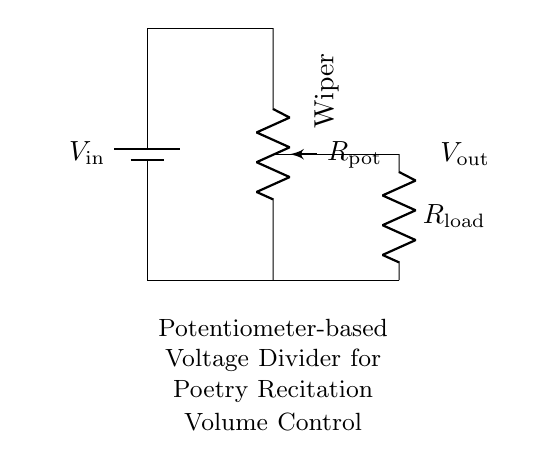What is the input voltage in the circuit? The input voltage, labeled as V in the circuit, is indicated near the battery component. The exact value is not stated, but the component signifies the voltage source for the circuit.
Answer: V in What does the potentiometer control in this circuit? In this circuit, the potentiometer is used to adjust the volume of the audio. It acts as a variable resistor, allowing the user to change the output voltage based on the wiper's position.
Answer: Audio volume What is the output voltage related to? The output voltage in this circuit, labeled V out, is determined by the position of the wiper on the potentiometer. It represents the voltage drop across the load resistor connected to the output.
Answer: Load resistor How is the potentiometer connected in this circuit? The potentiometer is connected in series within the voltage dividing network. One end connects to the input voltage while the wiper connects to the output, with the other end connected to ground.
Answer: In series What role does the load resistor play in the voltage divider? The load resistor interacts with the output voltage, affecting the power delivered to the connected load, such as speakers in a recitation system. It ensures proper functioning of the voltage divider by defining the output characteristics.
Answer: Ensures function What happens if the potentiometer is turned to one extreme? If the potentiometer is turned to one extreme, the wiper either connects to the input voltage (max volume) or to ground (min volume), resulting in maximum or minimum output voltage, affecting audio volume substantially.
Answer: Max or min volume 